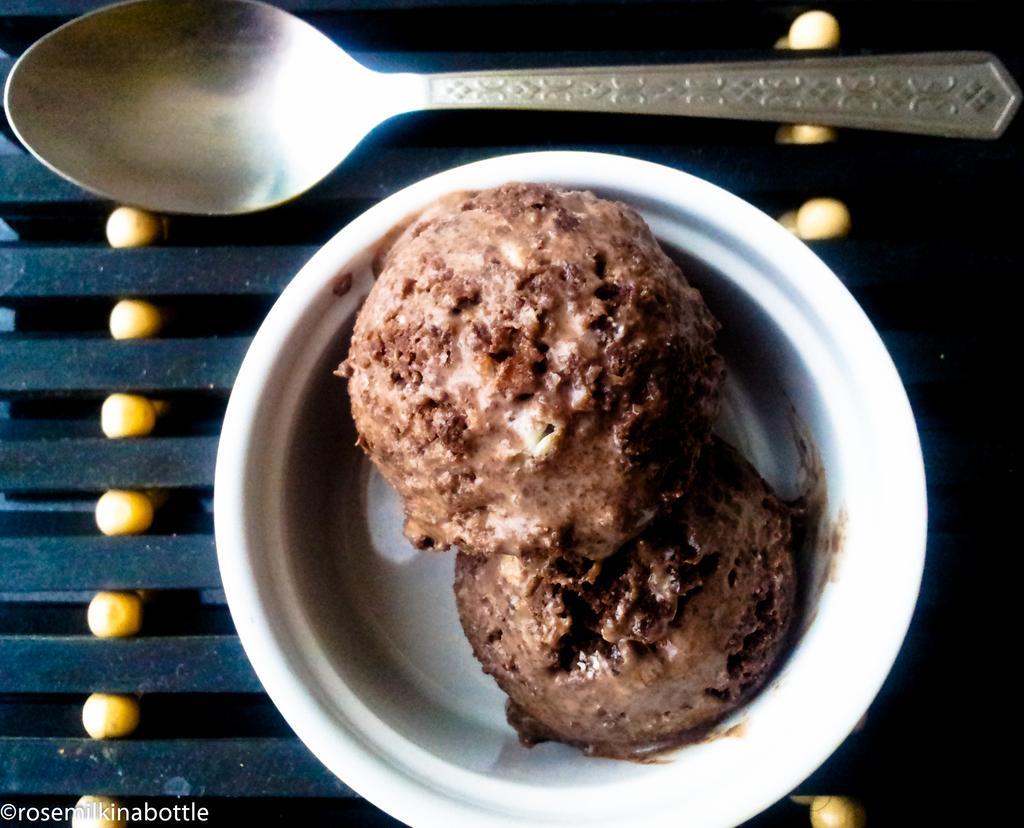Could you give a brief overview of what you see in this image? In the picture we can see a white color bowl with two scoops of chocolate ice cream and beside it we can see a spoon. 